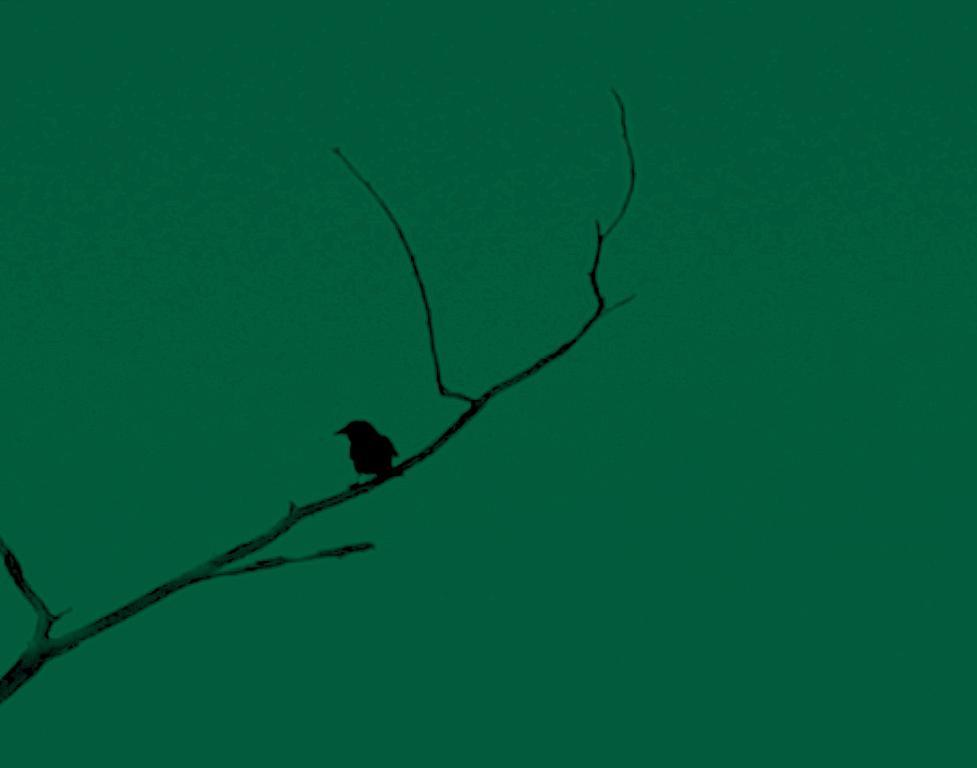What type of animal is in the image? There is a bird in the image. Where is the bird located in the image? The bird is on the branch of a tree. What can be seen in the background of the image? The sky is visible in the background of the image. What type of toy is the bird playing with in the image? There is no toy present in the image; it is a bird on the branch of a tree. 